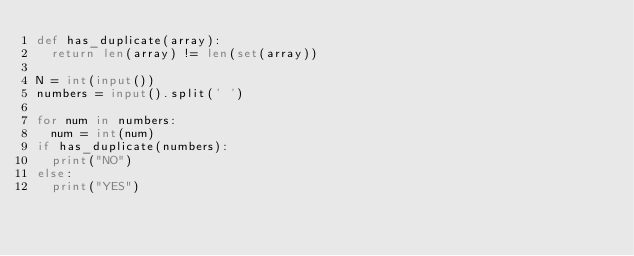Convert code to text. <code><loc_0><loc_0><loc_500><loc_500><_Python_>def has_duplicate(array):
  return len(array) != len(set(array))

N = int(input())
numbers = input().split(' ')

for num in numbers:
  num = int(num)
if has_duplicate(numbers):
  print("NO")
else:
  print("YES")</code> 